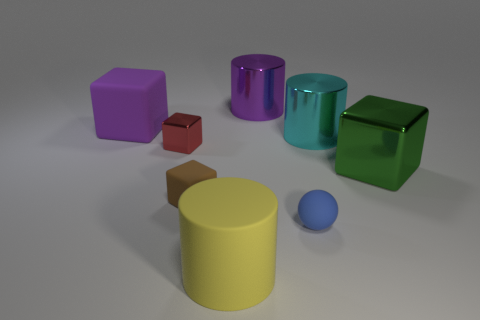What can you tell me about the texture of the objects? The objects in the image display a mix of textures. The yellow cylinder and the blue ball have smooth textures, implying a soft, possibly rubbery material. In contrast, the purple and green cubes, as well as the turquoise cylinder, appear glossy, suggesting that they are made of a harder, more reflective material like plastic. 